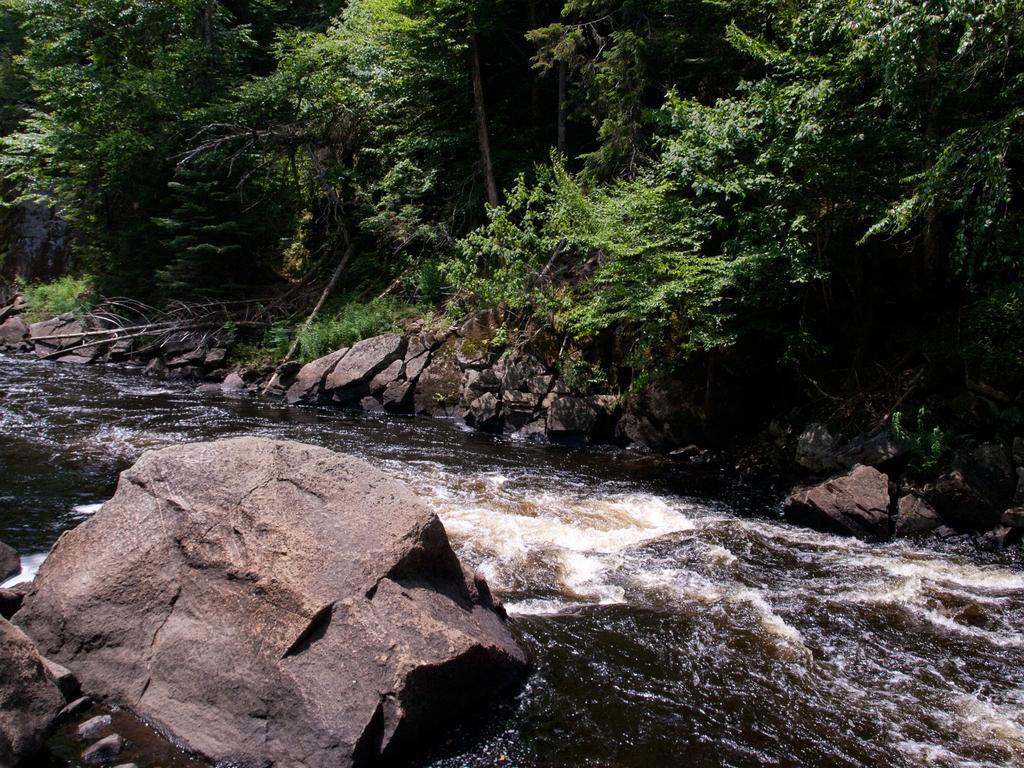Can you describe this image briefly? This is water and there are rocks. In the background we can see trees. 